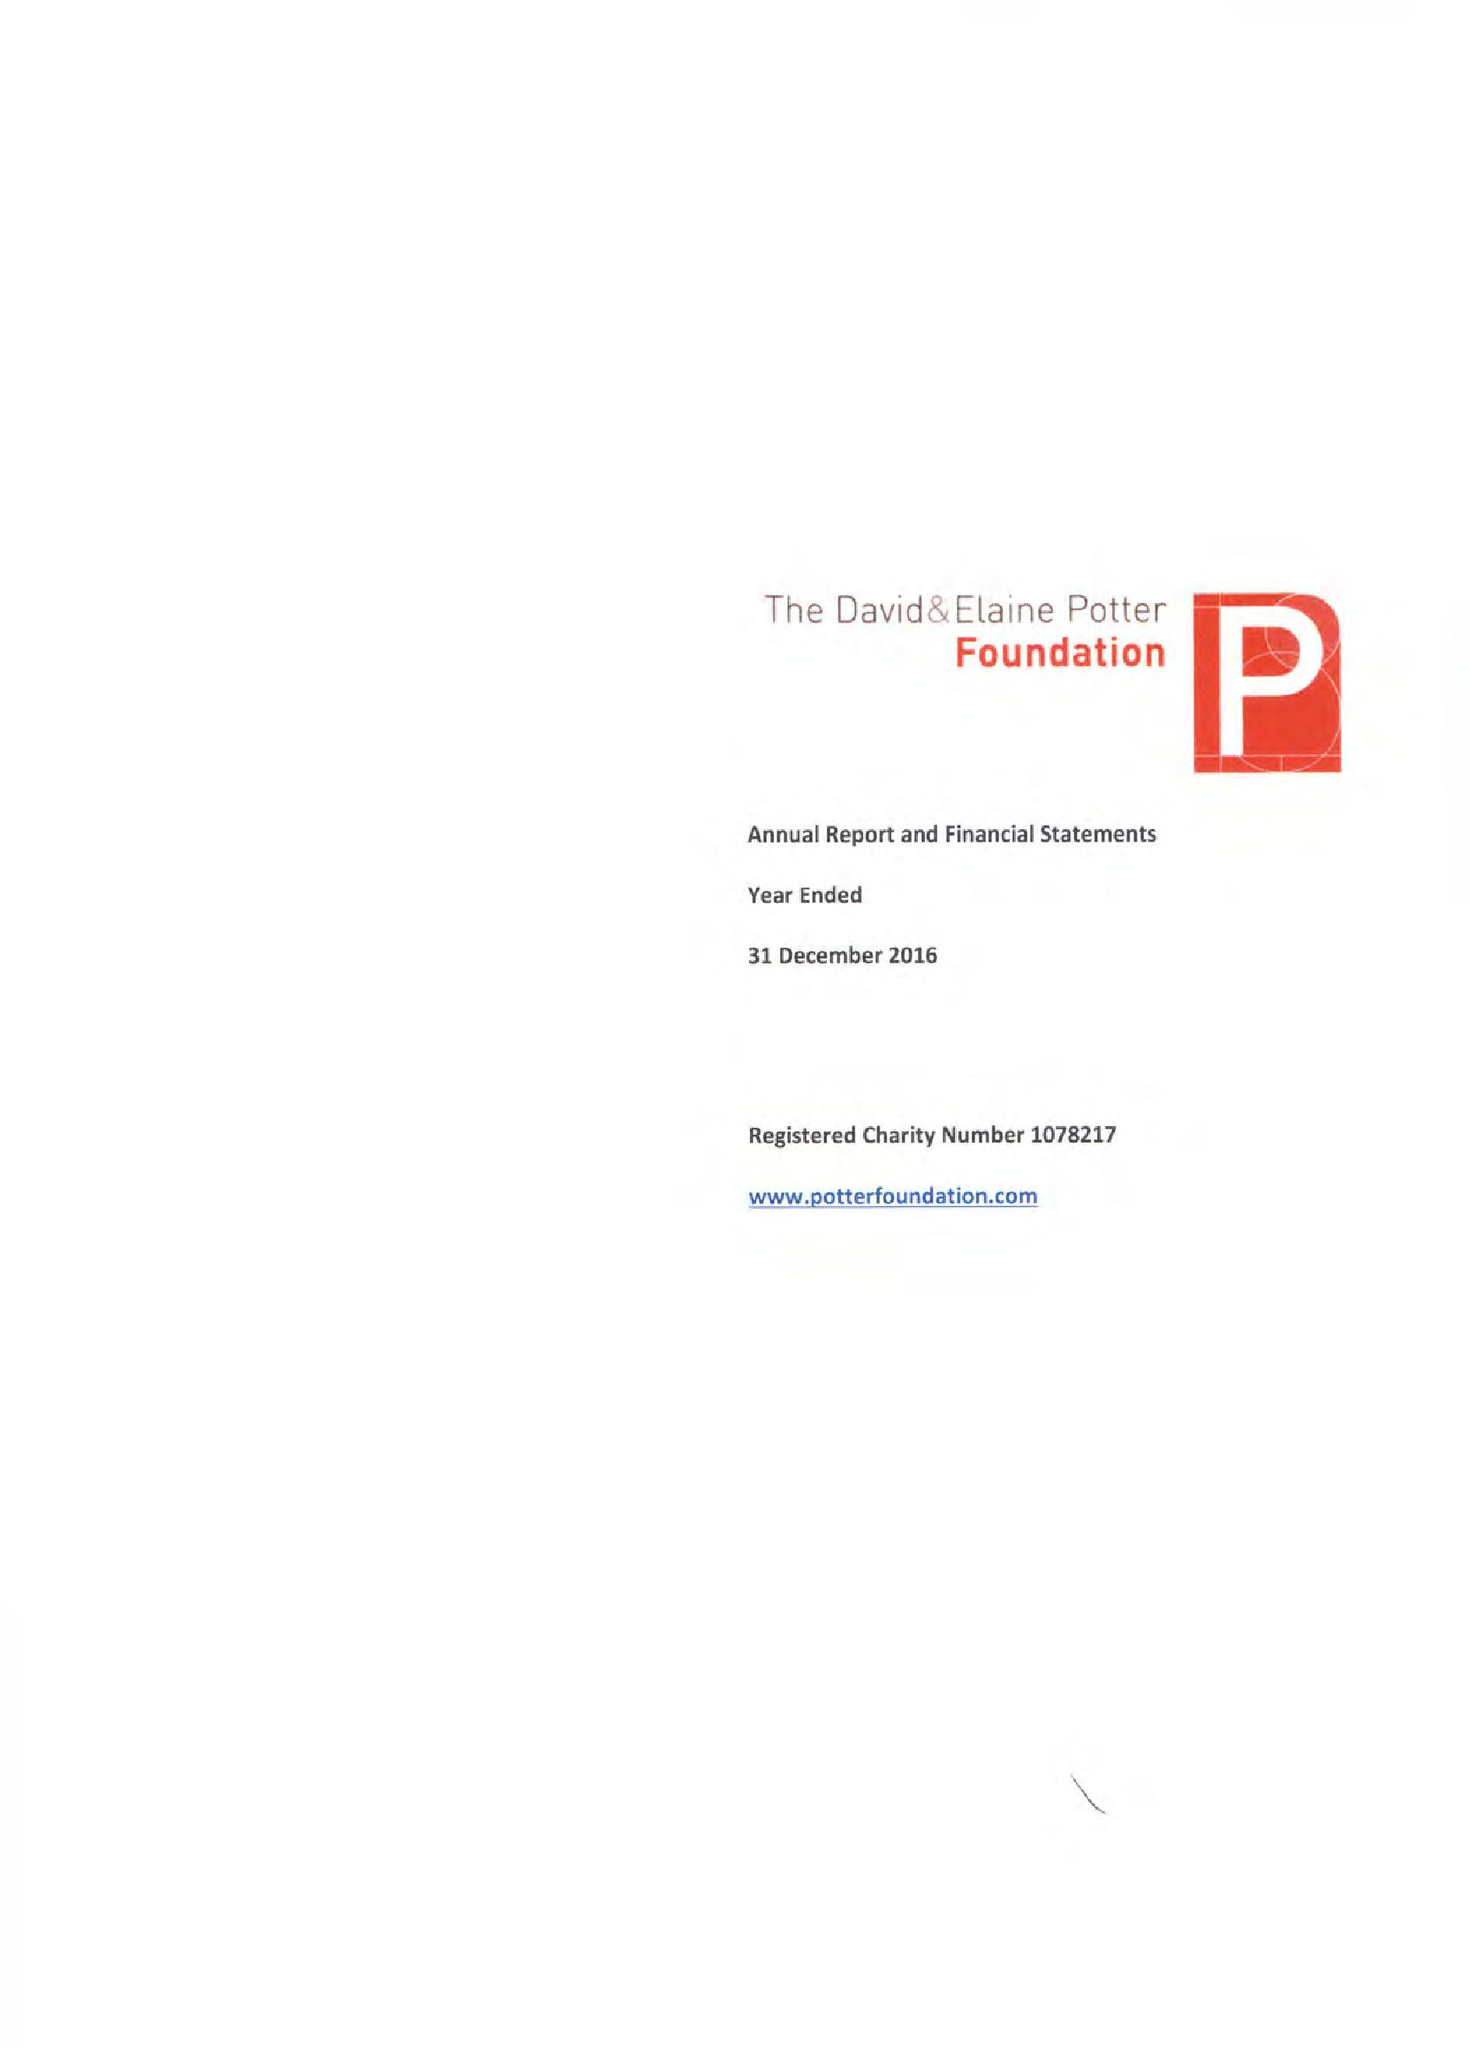What is the value for the address__postcode?
Answer the question using a single word or phrase. W1G 9YQ 